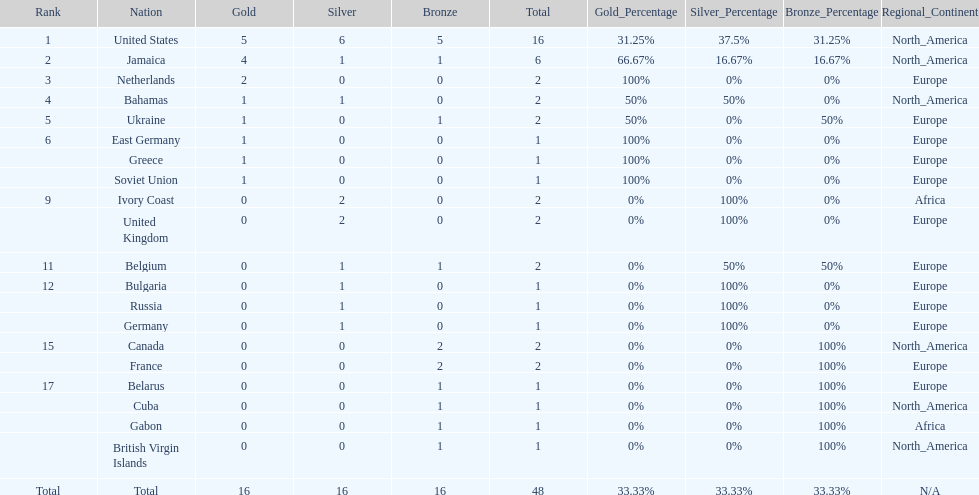Could you parse the entire table? {'header': ['Rank', 'Nation', 'Gold', 'Silver', 'Bronze', 'Total', 'Gold_Percentage', 'Silver_Percentage', 'Bronze_Percentage', 'Regional_Continent'], 'rows': [['1', 'United States', '5', '6', '5', '16', '31.25%', '37.5%', '31.25%', 'North_America'], ['2', 'Jamaica', '4', '1', '1', '6', '66.67%', '16.67%', '16.67%', 'North_America'], ['3', 'Netherlands', '2', '0', '0', '2', '100%', '0%', '0%', 'Europe'], ['4', 'Bahamas', '1', '1', '0', '2', '50%', '50%', '0%', 'North_America'], ['5', 'Ukraine', '1', '0', '1', '2', '50%', '0%', '50%', 'Europe'], ['6', 'East Germany', '1', '0', '0', '1', '100%', '0%', '0%', 'Europe'], ['', 'Greece', '1', '0', '0', '1', '100%', '0%', '0%', 'Europe'], ['', 'Soviet Union', '1', '0', '0', '1', '100%', '0%', '0%', 'Europe'], ['9', 'Ivory Coast', '0', '2', '0', '2', '0%', '100%', '0%', 'Africa'], ['', 'United Kingdom', '0', '2', '0', '2', '0%', '100%', '0%', 'Europe'], ['11', 'Belgium', '0', '1', '1', '2', '0%', '50%', '50%', 'Europe'], ['12', 'Bulgaria', '0', '1', '0', '1', '0%', '100%', '0%', 'Europe'], ['', 'Russia', '0', '1', '0', '1', '0%', '100%', '0%', 'Europe'], ['', 'Germany', '0', '1', '0', '1', '0%', '100%', '0%', 'Europe'], ['15', 'Canada', '0', '0', '2', '2', '0%', '0%', '100%', 'North_America'], ['', 'France', '0', '0', '2', '2', '0%', '0%', '100%', 'Europe'], ['17', 'Belarus', '0', '0', '1', '1', '0%', '0%', '100%', 'Europe'], ['', 'Cuba', '0', '0', '1', '1', '0%', '0%', '100%', 'North_America'], ['', 'Gabon', '0', '0', '1', '1', '0%', '0%', '100%', 'Africa'], ['', 'British Virgin Islands', '0', '0', '1', '1', '0%', '0%', '100%', 'North_America'], ['Total', 'Total', '16', '16', '16', '48', '33.33%', '33.33%', '33.33%', 'N/A']]} Which countries won at least 3 silver medals? United States. 